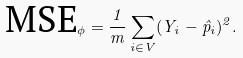<formula> <loc_0><loc_0><loc_500><loc_500>\text {MSE} _ { \phi } = \frac { 1 } { m } \sum _ { i \in V } ( Y _ { i } - \hat { p } _ { i } ) ^ { 2 } .</formula> 